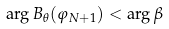<formula> <loc_0><loc_0><loc_500><loc_500>\arg B _ { \theta } ( \varphi _ { N + 1 } ) < \arg \beta</formula> 